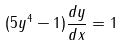<formula> <loc_0><loc_0><loc_500><loc_500>( 5 y ^ { 4 } - 1 ) \frac { d y } { d x } = 1</formula> 